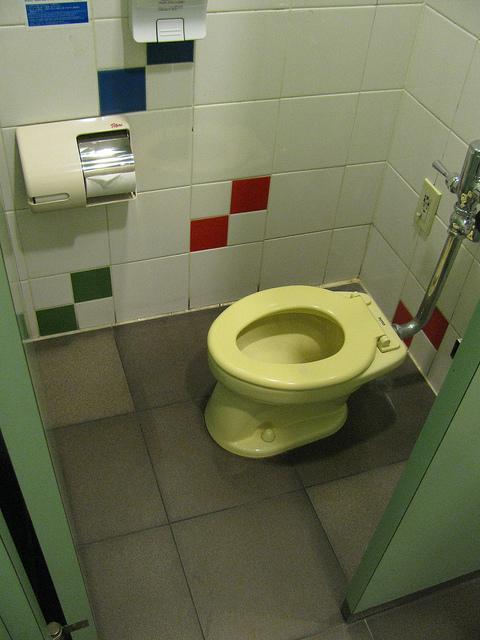How many chairs or sofas have a red pillow?
Give a very brief answer. 0. 